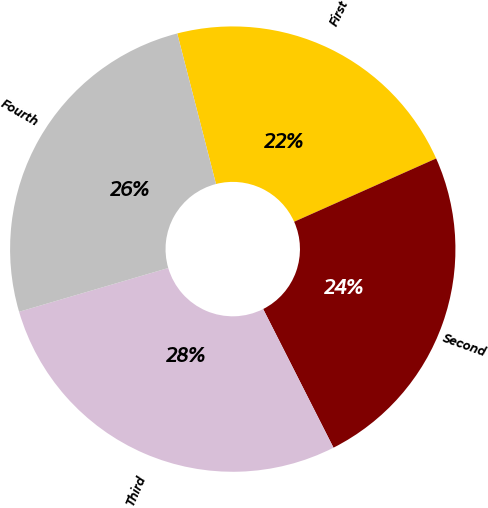Convert chart. <chart><loc_0><loc_0><loc_500><loc_500><pie_chart><fcel>First<fcel>Second<fcel>Third<fcel>Fourth<nl><fcel>22.34%<fcel>24.2%<fcel>27.93%<fcel>25.53%<nl></chart> 